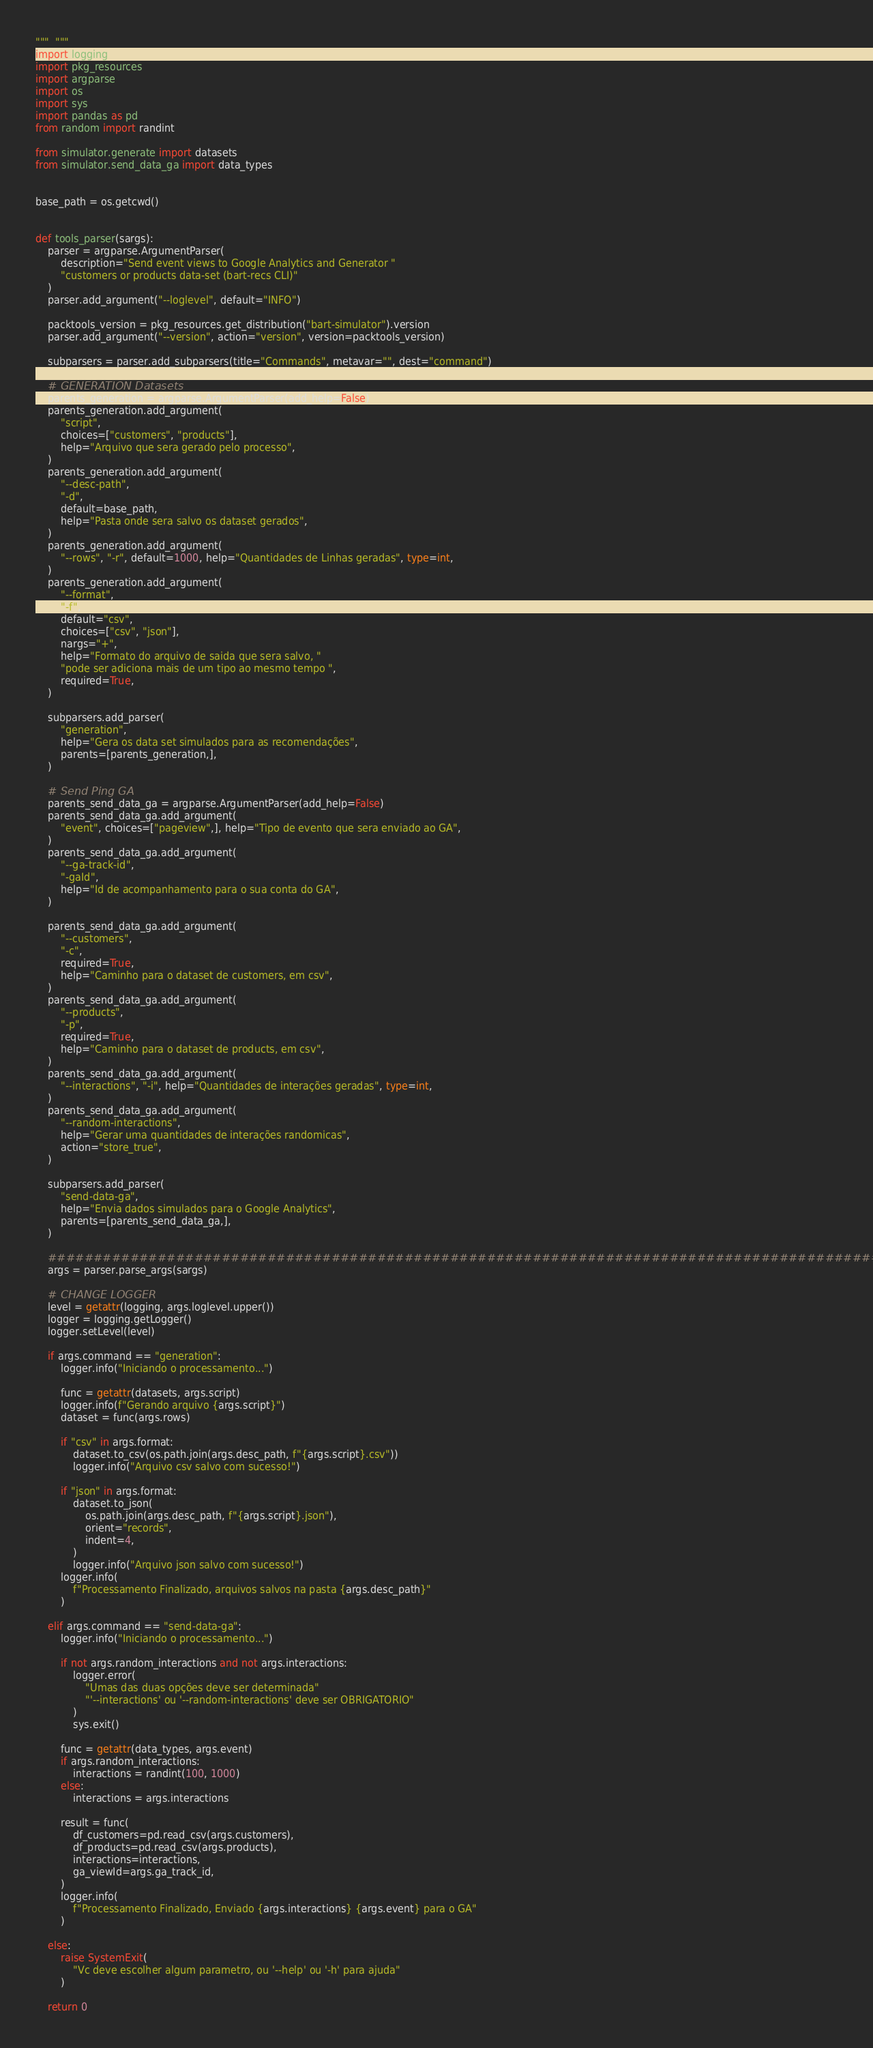Convert code to text. <code><loc_0><loc_0><loc_500><loc_500><_Python_>"""  """
import logging
import pkg_resources
import argparse
import os
import sys
import pandas as pd
from random import randint

from simulator.generate import datasets
from simulator.send_data_ga import data_types


base_path = os.getcwd()


def tools_parser(sargs):
    parser = argparse.ArgumentParser(
        description="Send event views to Google Analytics and Generator "
        "customers or products data-set (bart-recs CLI)"
    )
    parser.add_argument("--loglevel", default="INFO")

    packtools_version = pkg_resources.get_distribution("bart-simulator").version
    parser.add_argument("--version", action="version", version=packtools_version)

    subparsers = parser.add_subparsers(title="Commands", metavar="", dest="command")

    # GENERATION Datasets
    parents_generation = argparse.ArgumentParser(add_help=False)
    parents_generation.add_argument(
        "script",
        choices=["customers", "products"],
        help="Arquivo que sera gerado pelo processo",
    )
    parents_generation.add_argument(
        "--desc-path",
        "-d",
        default=base_path,
        help="Pasta onde sera salvo os dataset gerados",
    )
    parents_generation.add_argument(
        "--rows", "-r", default=1000, help="Quantidades de Linhas geradas", type=int,
    )
    parents_generation.add_argument(
        "--format",
        "-f",
        default="csv",
        choices=["csv", "json"],
        nargs="+",
        help="Formato do arquivo de saida que sera salvo, "
        "pode ser adiciona mais de um tipo ao mesmo tempo ",
        required=True,
    )

    subparsers.add_parser(
        "generation",
        help="Gera os data set simulados para as recomendações",
        parents=[parents_generation,],
    )

    # Send Ping GA
    parents_send_data_ga = argparse.ArgumentParser(add_help=False)
    parents_send_data_ga.add_argument(
        "event", choices=["pageview",], help="Tipo de evento que sera enviado ao GA",
    )
    parents_send_data_ga.add_argument(
        "--ga-track-id",
        "-gaId",
        help="Id de acompanhamento para o sua conta do GA",
    )

    parents_send_data_ga.add_argument(
        "--customers",
        "-c",
        required=True,
        help="Caminho para o dataset de customers, em csv",
    )
    parents_send_data_ga.add_argument(
        "--products",
        "-p",
        required=True,
        help="Caminho para o dataset de products, em csv",
    )
    parents_send_data_ga.add_argument(
        "--interactions", "-i", help="Quantidades de interações geradas", type=int,
    )
    parents_send_data_ga.add_argument(
        "--random-interactions",
        help="Gerar uma quantidades de interações randomicas",
        action="store_true",
    )

    subparsers.add_parser(
        "send-data-ga",
        help="Envia dados simulados para o Google Analytics",
        parents=[parents_send_data_ga,],
    )

    ################################################################################################
    args = parser.parse_args(sargs)

    # CHANGE LOGGER
    level = getattr(logging, args.loglevel.upper())
    logger = logging.getLogger()
    logger.setLevel(level)

    if args.command == "generation":
        logger.info("Iniciando o processamento...")

        func = getattr(datasets, args.script)
        logger.info(f"Gerando arquivo {args.script}")
        dataset = func(args.rows)

        if "csv" in args.format:
            dataset.to_csv(os.path.join(args.desc_path, f"{args.script}.csv"))
            logger.info("Arquivo csv salvo com sucesso!")

        if "json" in args.format:
            dataset.to_json(
                os.path.join(args.desc_path, f"{args.script}.json"),
                orient="records",
                indent=4,
            )
            logger.info("Arquivo json salvo com sucesso!")
        logger.info(
            f"Processamento Finalizado, arquivos salvos na pasta {args.desc_path}"
        )

    elif args.command == "send-data-ga":
        logger.info("Iniciando o processamento...")

        if not args.random_interactions and not args.interactions:
            logger.error(
                "Umas das duas opções deve ser determinada"
                "'--interactions' ou '--random-interactions' deve ser OBRIGATORIO"
            )
            sys.exit()

        func = getattr(data_types, args.event)
        if args.random_interactions:
            interactions = randint(100, 1000)
        else:
            interactions = args.interactions

        result = func(
            df_customers=pd.read_csv(args.customers),
            df_products=pd.read_csv(args.products),
            interactions=interactions,
            ga_viewId=args.ga_track_id,
        )
        logger.info(
            f"Processamento Finalizado, Enviado {args.interactions} {args.event} para o GA"
        )

    else:
        raise SystemExit(
            "Vc deve escolher algum parametro, ou '--help' ou '-h' para ajuda"
        )

    return 0
</code> 